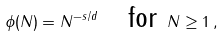Convert formula to latex. <formula><loc_0><loc_0><loc_500><loc_500>\phi ( N ) = N ^ { - s / d } \quad \text {for } N \geq 1 \, ,</formula> 